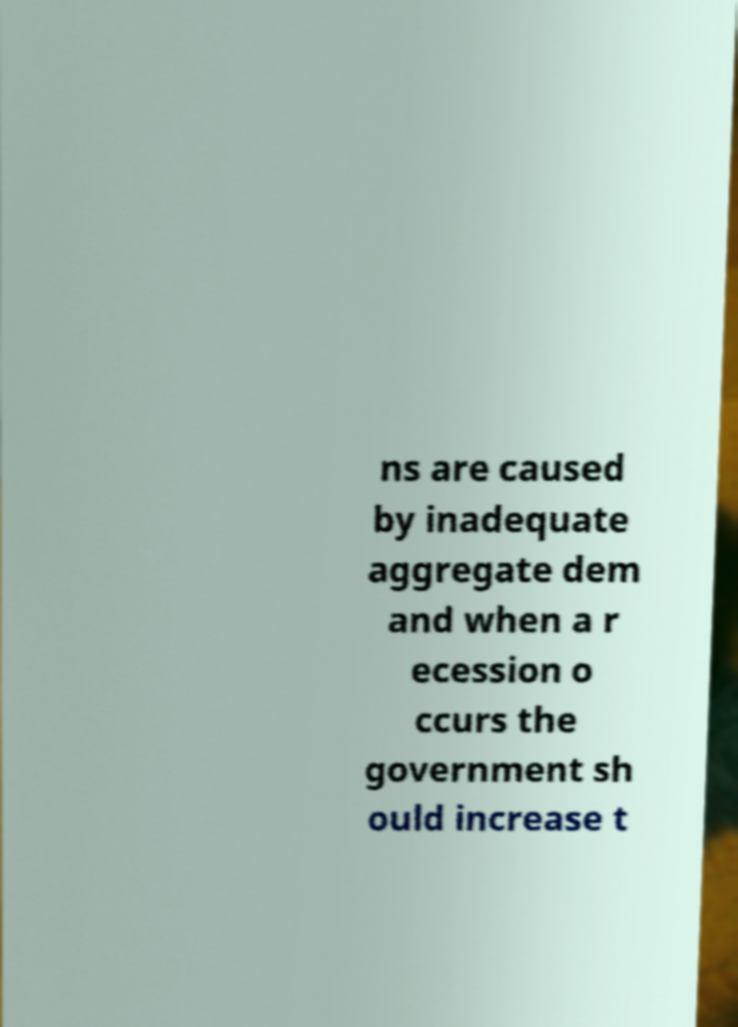What messages or text are displayed in this image? I need them in a readable, typed format. ns are caused by inadequate aggregate dem and when a r ecession o ccurs the government sh ould increase t 